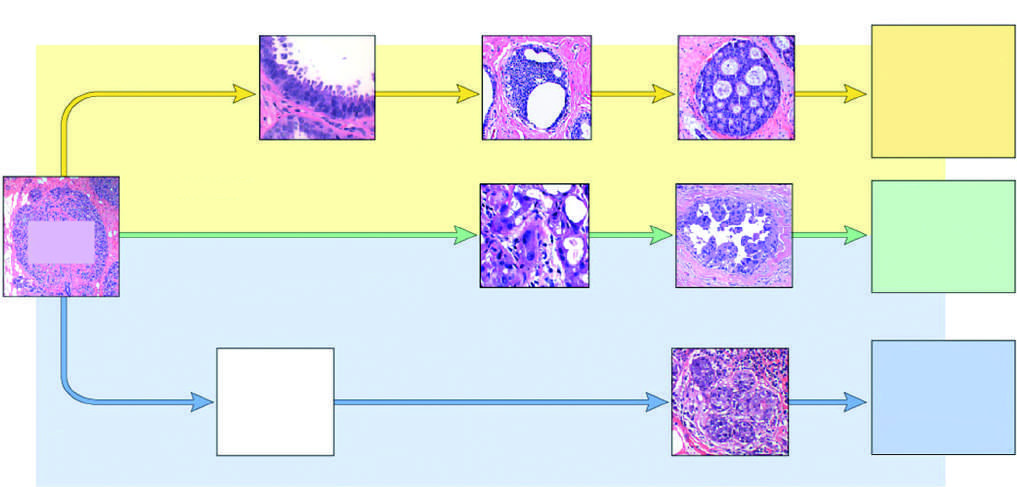what is a possible precursor lesion, which shares features with apocrine dcis?
Answer the question using a single word or phrase. Atypical apocrine adenosis 